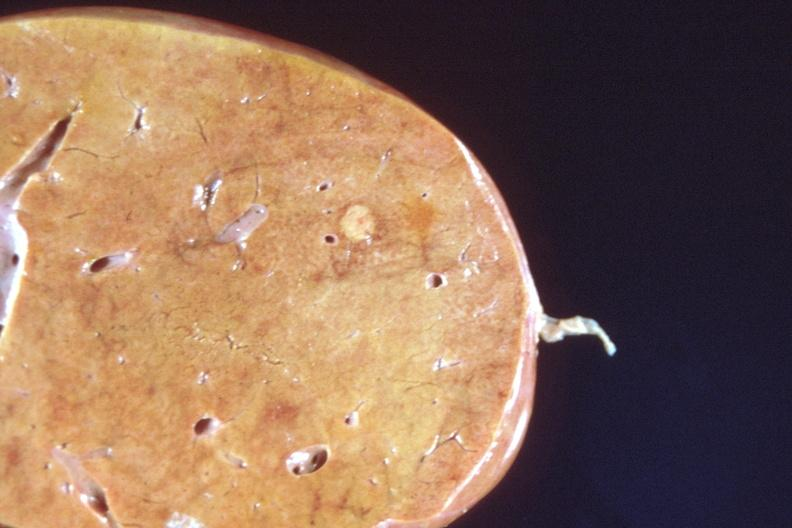does this image show liver, metastatic breast cancer?
Answer the question using a single word or phrase. Yes 